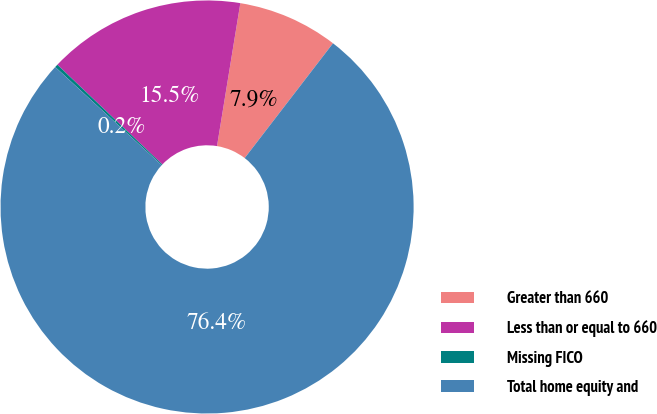Convert chart to OTSL. <chart><loc_0><loc_0><loc_500><loc_500><pie_chart><fcel>Greater than 660<fcel>Less than or equal to 660<fcel>Missing FICO<fcel>Total home equity and<nl><fcel>7.86%<fcel>15.48%<fcel>0.24%<fcel>76.41%<nl></chart> 